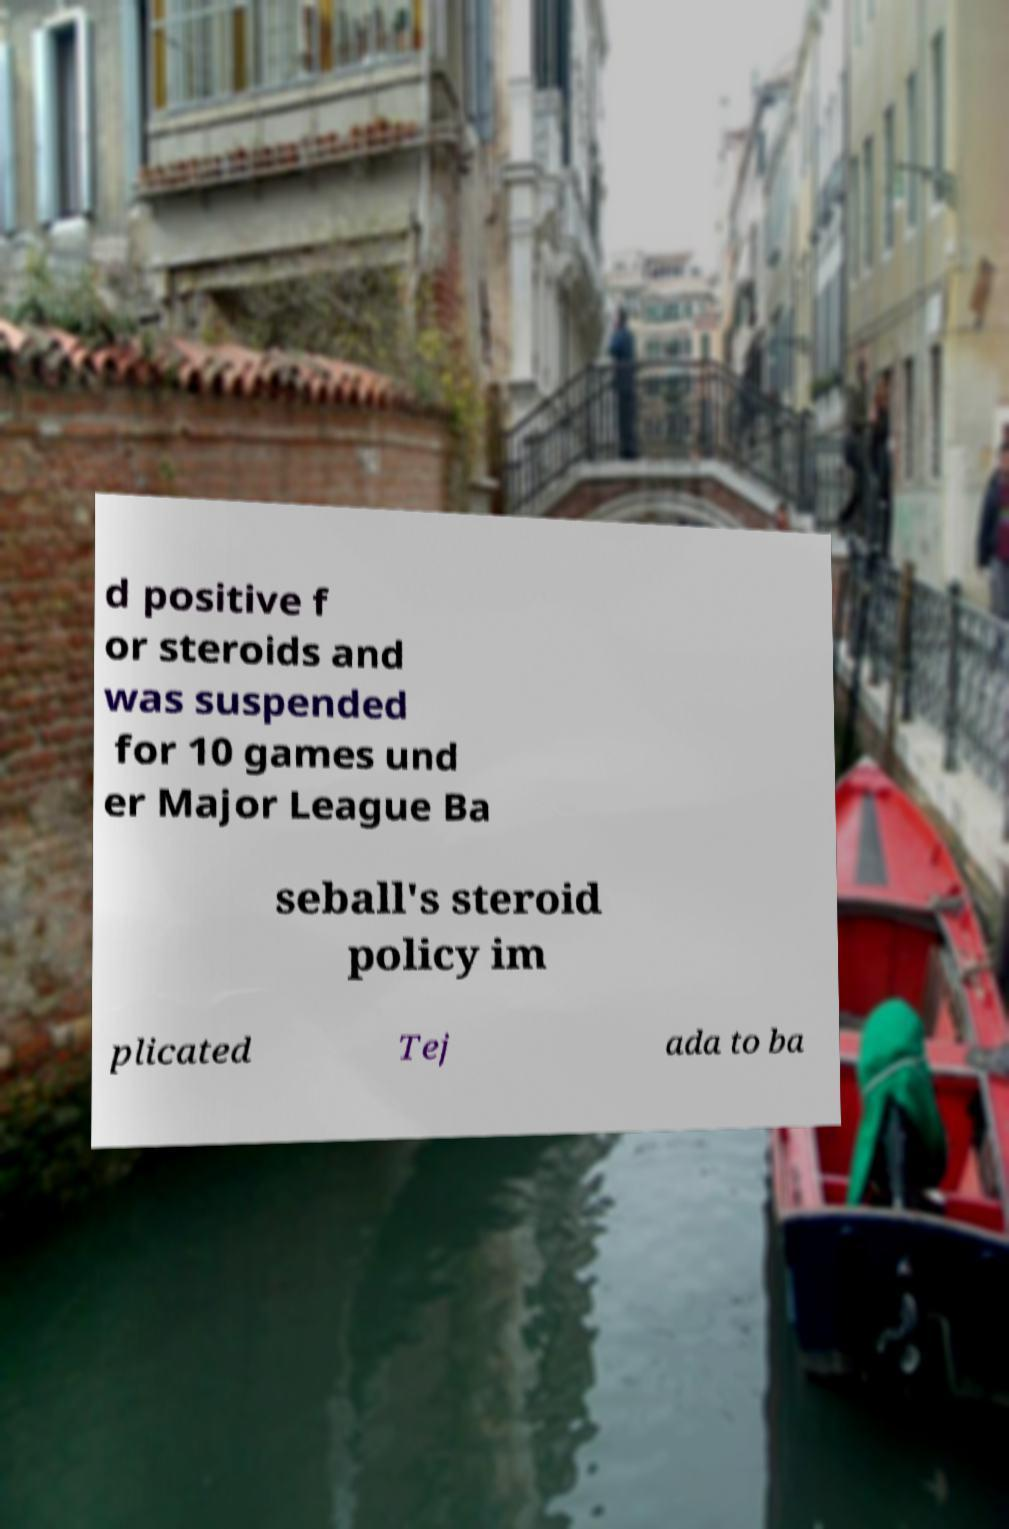I need the written content from this picture converted into text. Can you do that? d positive f or steroids and was suspended for 10 games und er Major League Ba seball's steroid policy im plicated Tej ada to ba 